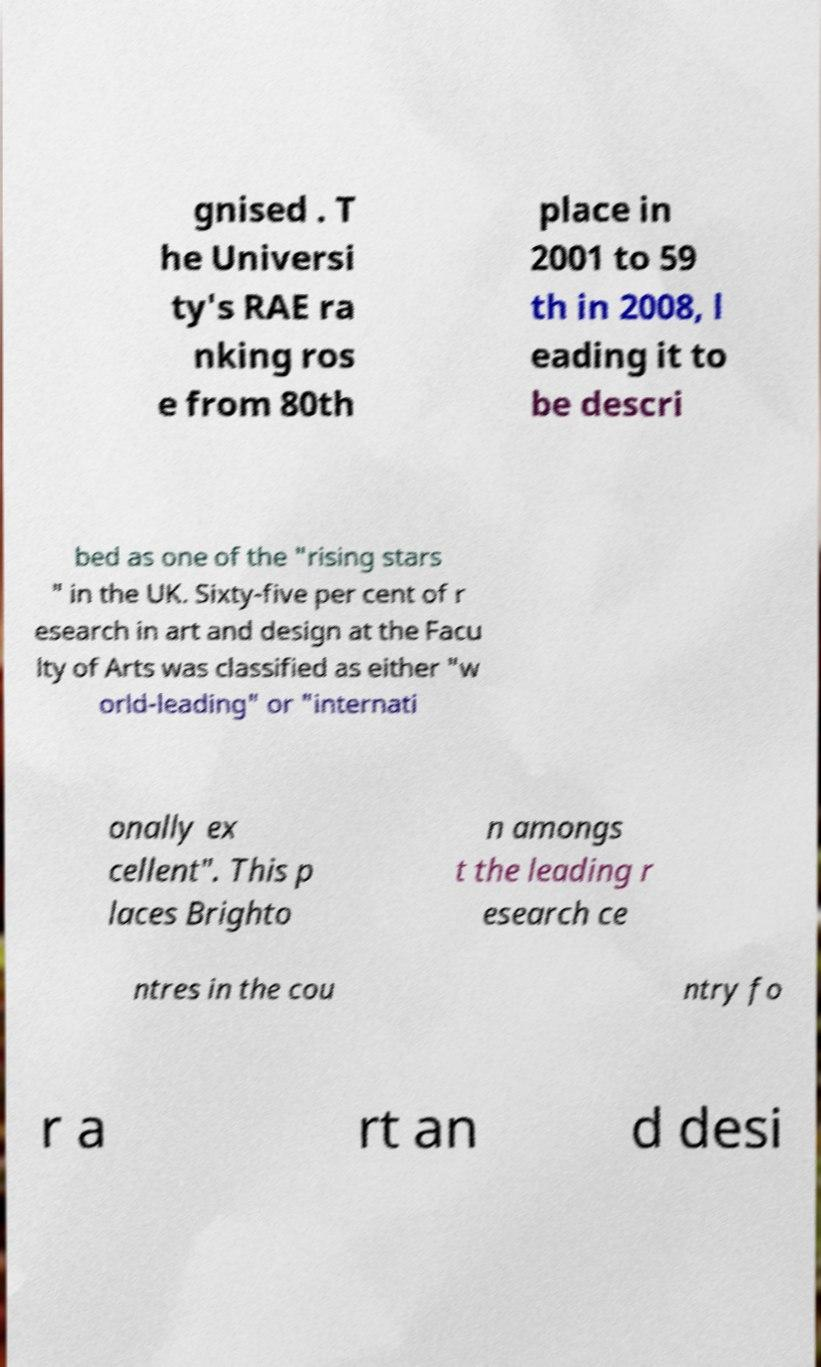Could you extract and type out the text from this image? gnised . T he Universi ty's RAE ra nking ros e from 80th place in 2001 to 59 th in 2008, l eading it to be descri bed as one of the "rising stars " in the UK. Sixty-five per cent of r esearch in art and design at the Facu lty of Arts was classified as either "w orld-leading" or "internati onally ex cellent". This p laces Brighto n amongs t the leading r esearch ce ntres in the cou ntry fo r a rt an d desi 